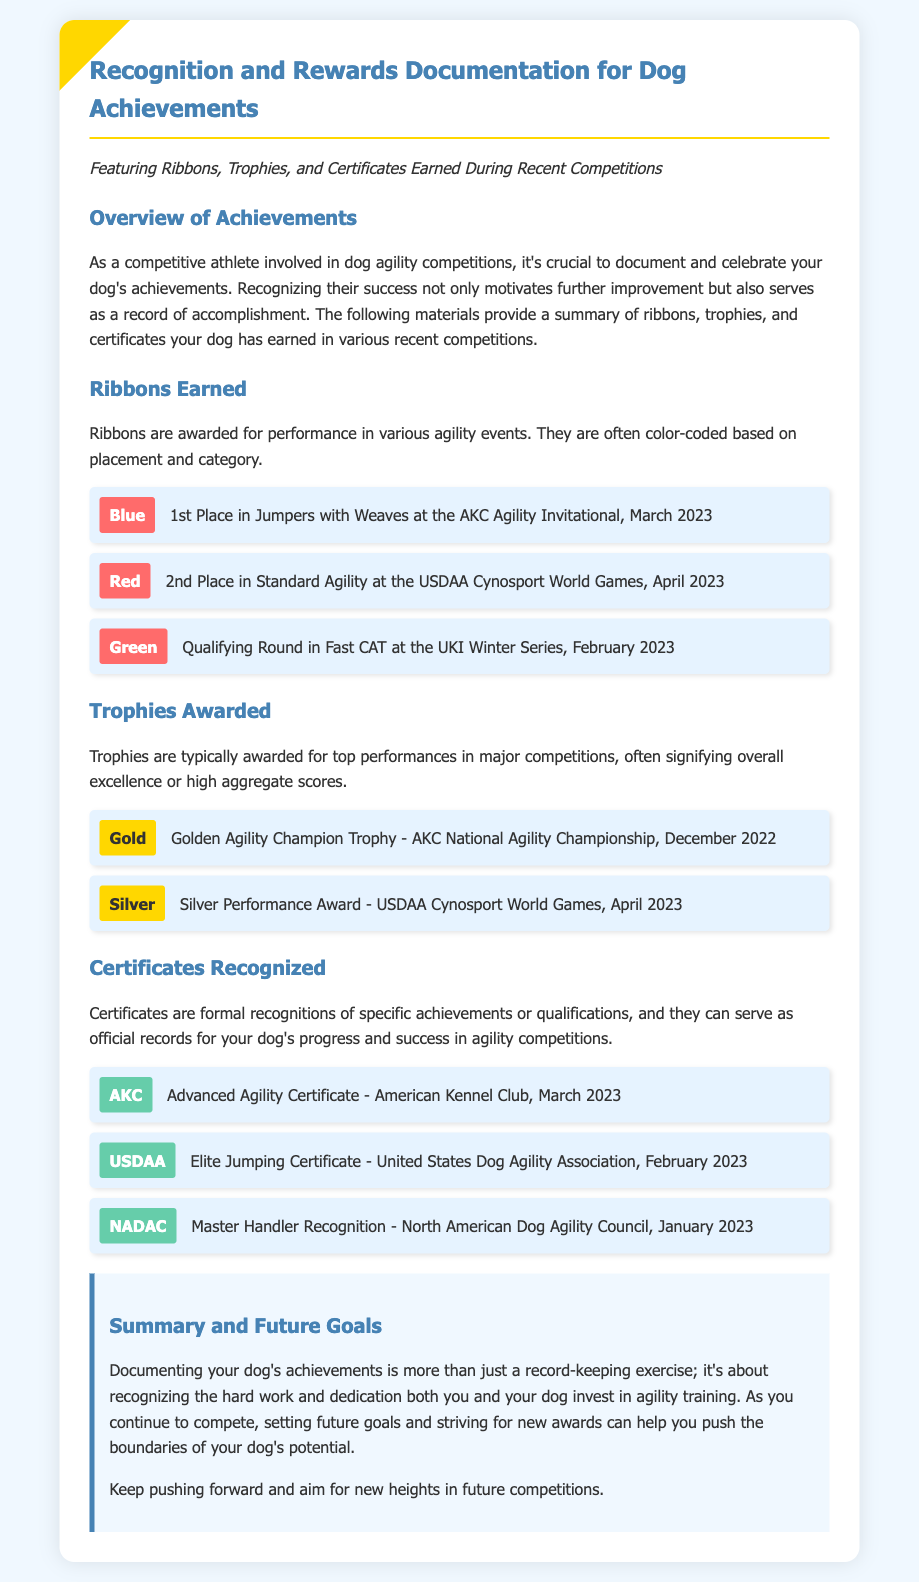What is the title of the document? The title is displayed prominently at the top of the document, reflecting its main subject matter.
Answer: Recognition and Rewards Documentation for Dog Achievements How many ribbons are listed in the document? The document enumerates the ribbons earned in various competitions, which can be counted in the relevant section.
Answer: 3 What color ribbon was awarded for 1st place in Jumpers with Weaves? The specific color of the ribbon for this achievement is mentioned clearly in the ribbons section.
Answer: Blue What was the trophy awarded at the AKC National Agility Championship? The document specifies the trophy awarded at this event in the trophies section.
Answer: Golden Agility Champion Trophy What is the date of the Advanced Agility Certificate? The certificate section includes a specific date associated with this achievement.
Answer: March 2023 Which organization issued the Master Handler Recognition? The document provides the name of the organization responsible for this specific certificate.
Answer: North American Dog Agility Council What is the main purpose of documenting dog achievements mentioned in the summary? The summary highlights the rationale behind maintaining records of achievements in dog agility.
Answer: Recognizing hard work How many trophies are mentioned in the document? A count can be taken from the trophies section of the document to determine the total.
Answer: 2 What was earned in February 2023 according to the document? This date is associated with achievements in the ribbons, trophies, or certificates sections that can be cited directly.
Answer: Qualifying Round in Fast CAT 